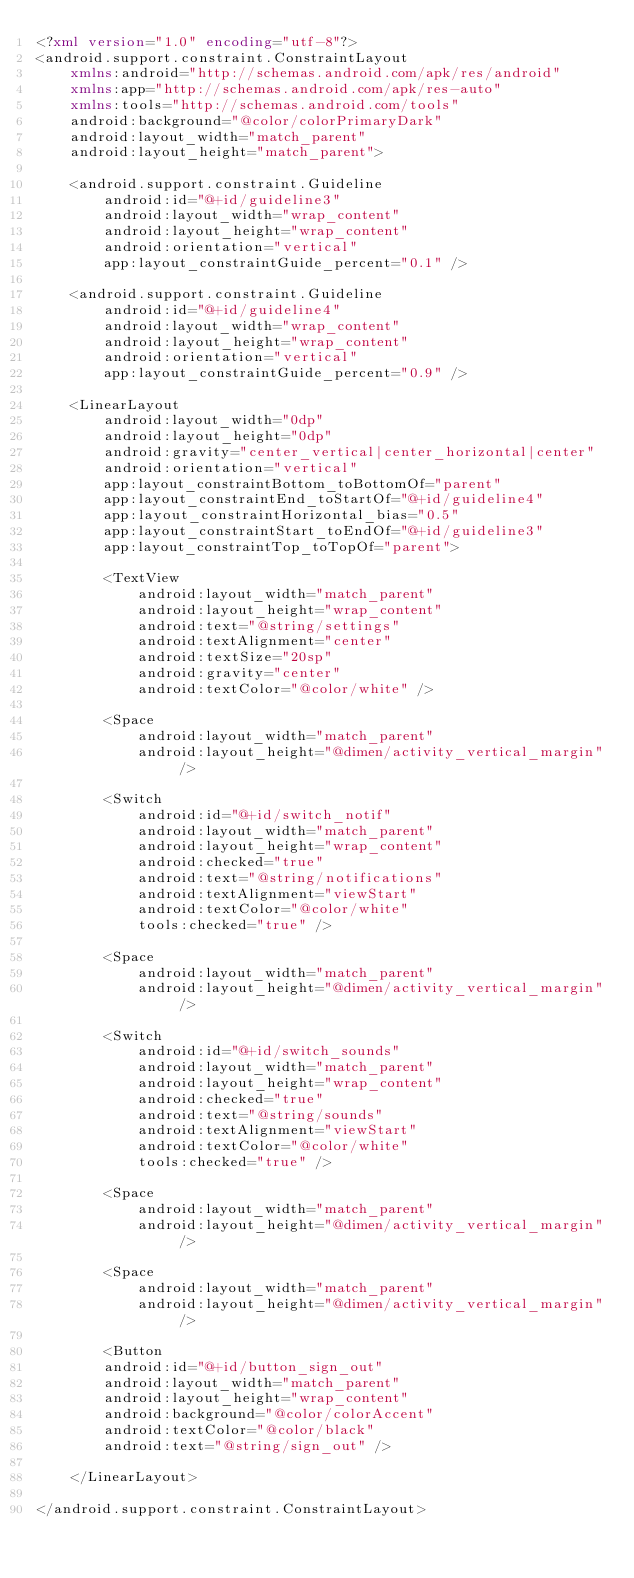Convert code to text. <code><loc_0><loc_0><loc_500><loc_500><_XML_><?xml version="1.0" encoding="utf-8"?>
<android.support.constraint.ConstraintLayout
    xmlns:android="http://schemas.android.com/apk/res/android"
    xmlns:app="http://schemas.android.com/apk/res-auto"
    xmlns:tools="http://schemas.android.com/tools"
    android:background="@color/colorPrimaryDark"
    android:layout_width="match_parent"
    android:layout_height="match_parent">

    <android.support.constraint.Guideline
        android:id="@+id/guideline3"
        android:layout_width="wrap_content"
        android:layout_height="wrap_content"
        android:orientation="vertical"
        app:layout_constraintGuide_percent="0.1" />

    <android.support.constraint.Guideline
        android:id="@+id/guideline4"
        android:layout_width="wrap_content"
        android:layout_height="wrap_content"
        android:orientation="vertical"
        app:layout_constraintGuide_percent="0.9" />

    <LinearLayout
        android:layout_width="0dp"
        android:layout_height="0dp"
        android:gravity="center_vertical|center_horizontal|center"
        android:orientation="vertical"
        app:layout_constraintBottom_toBottomOf="parent"
        app:layout_constraintEnd_toStartOf="@+id/guideline4"
        app:layout_constraintHorizontal_bias="0.5"
        app:layout_constraintStart_toEndOf="@+id/guideline3"
        app:layout_constraintTop_toTopOf="parent">

        <TextView
            android:layout_width="match_parent"
            android:layout_height="wrap_content"
            android:text="@string/settings"
            android:textAlignment="center"
            android:textSize="20sp"
            android:gravity="center"
            android:textColor="@color/white" />

        <Space
            android:layout_width="match_parent"
            android:layout_height="@dimen/activity_vertical_margin" />

        <Switch
            android:id="@+id/switch_notif"
            android:layout_width="match_parent"
            android:layout_height="wrap_content"
            android:checked="true"
            android:text="@string/notifications"
            android:textAlignment="viewStart"
            android:textColor="@color/white"
            tools:checked="true" />

        <Space
            android:layout_width="match_parent"
            android:layout_height="@dimen/activity_vertical_margin" />

        <Switch
            android:id="@+id/switch_sounds"
            android:layout_width="match_parent"
            android:layout_height="wrap_content"
            android:checked="true"
            android:text="@string/sounds"
            android:textAlignment="viewStart"
            android:textColor="@color/white"
            tools:checked="true" />

        <Space
            android:layout_width="match_parent"
            android:layout_height="@dimen/activity_vertical_margin" />

        <Space
            android:layout_width="match_parent"
            android:layout_height="@dimen/activity_vertical_margin" />

        <Button
        android:id="@+id/button_sign_out"
        android:layout_width="match_parent"
        android:layout_height="wrap_content"
        android:background="@color/colorAccent"
        android:textColor="@color/black"
        android:text="@string/sign_out" />

    </LinearLayout>

</android.support.constraint.ConstraintLayout>
</code> 